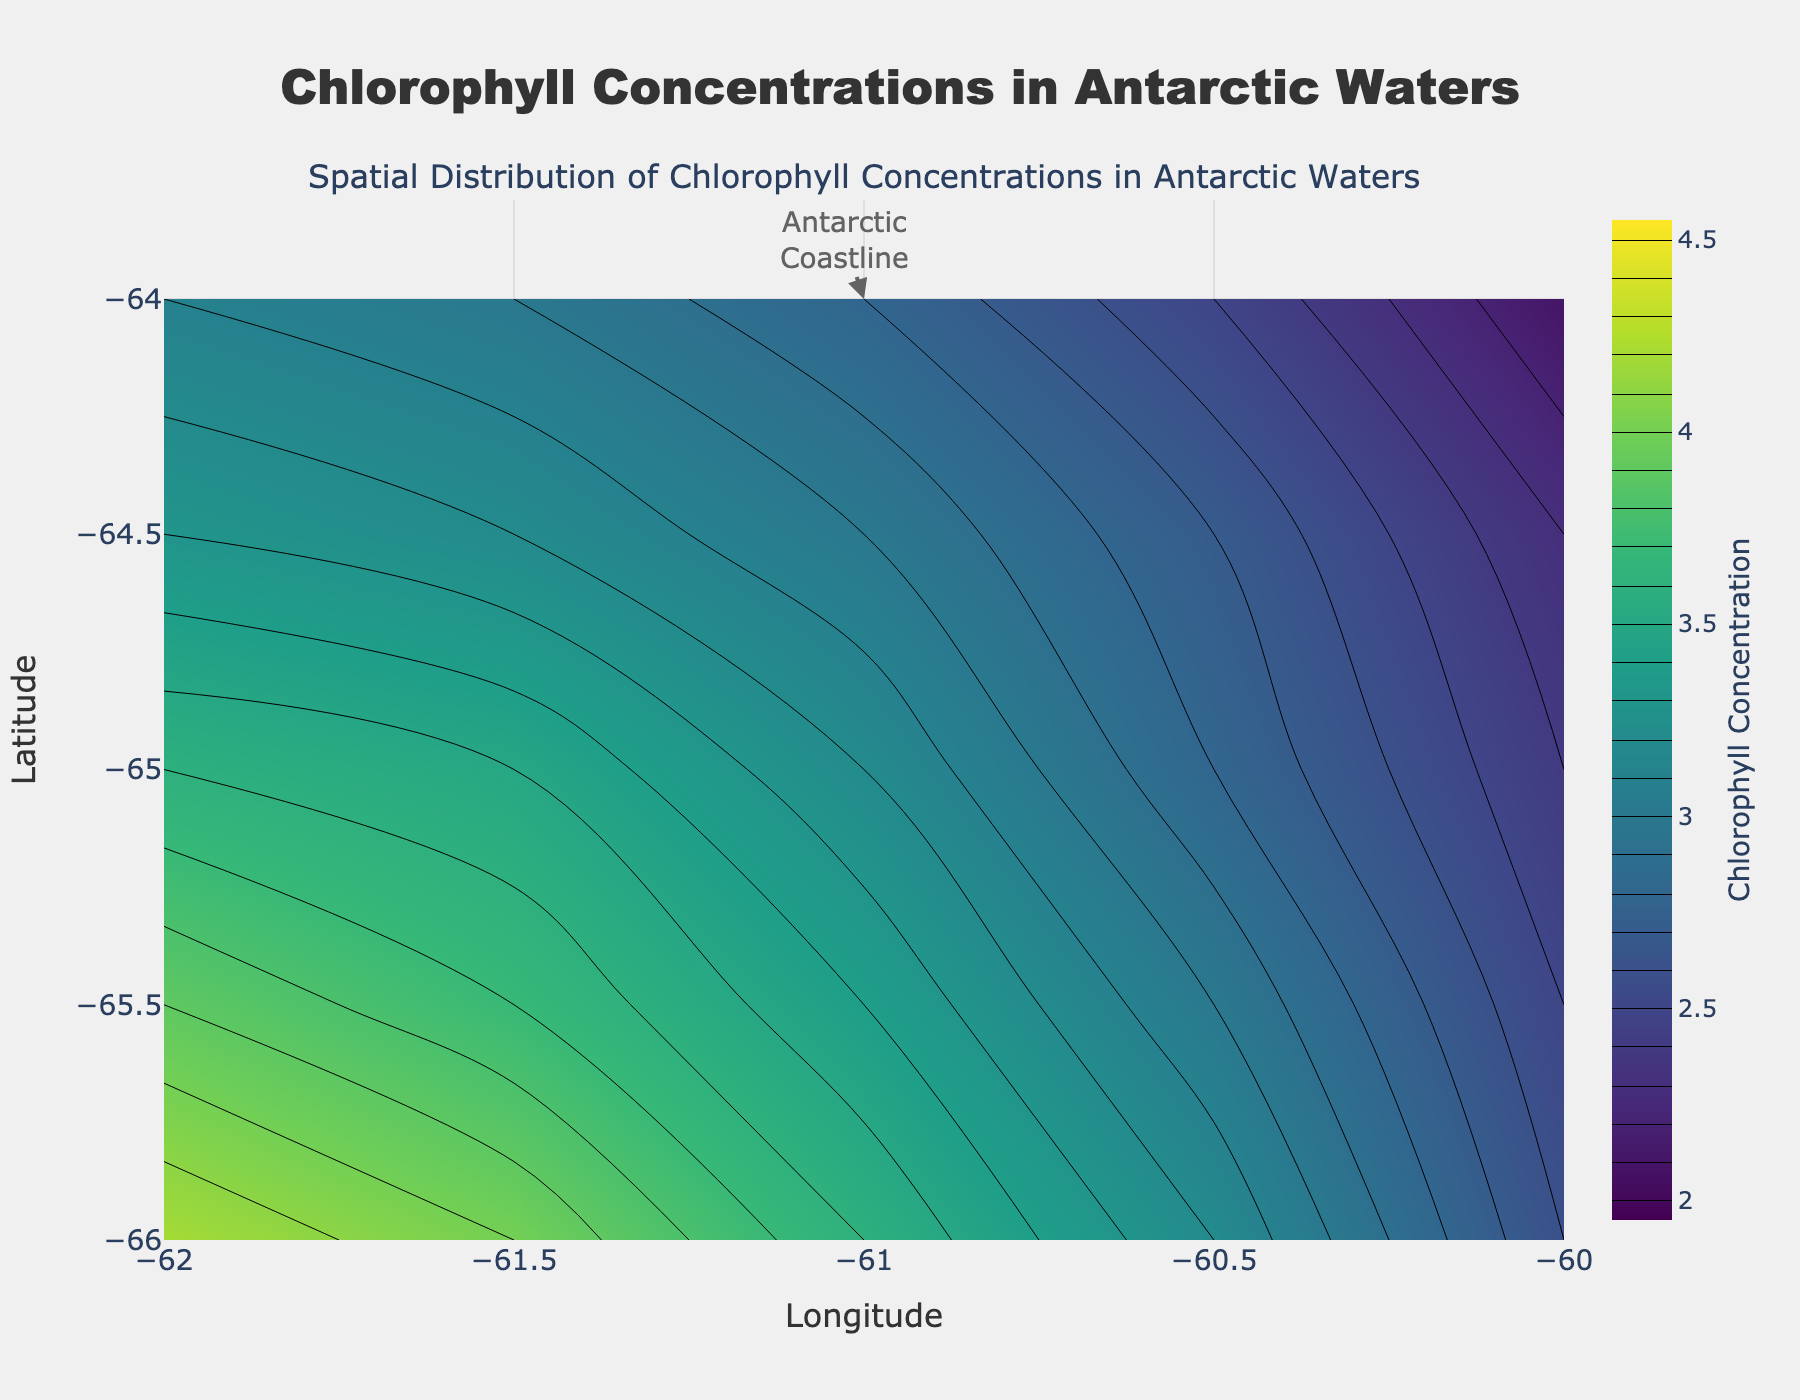What's the title of the figure? The title is located at the top center of the figure in large, bold font. It reads "Chlorophyll Concentrations in Antarctic Waters".
Answer: Chlorophyll Concentrations in Antarctic Waters What are the axis labels in the figure? The x-axis label, located at the bottom center of the plot, reads "Longitude". The y-axis label, located at the left center of the plot, reads "Latitude".
Answer: Longitude and Latitude What color scale is used in the contour plot? The color scale used in the plot is the 'Viridis' colorscale, which ranges from dark blue to yellow. This can be inferred from the color gradient in the contour plot.
Answer: Viridis What's the range of chlorophyll concentration in this plot? The color bar to the right of the contour plot indicates that the chlorophyll concentration ranges from 2 to 4.5. The color bar has labels that show these values.
Answer: 2 to 4.5 Where is the highest concentration of chlorophyll found in the plot? The highest concentration of chlorophyll, indicated by the brightest yellow color in the plot, is located at the bottom right corner, around the coordinates (-66.0, -62.0).
Answer: Around (-66.0, -62.0) Compare the chlorophyll concentration at (-64.0, -60.0) and (-65.5, -61.5). Which one has a higher concentration? The contour plot shows that (-65.5, -61.5) has a concentration of around 3.7, while (-64.0, -60.0) has a concentration of around 2.1. Therefore, the point (-65.5, -61.5) has a higher concentration.
Answer: (-65.5, -61.5) What's the average chlorophyll concentration at the longitude -61.0? By observing the contour lines for the longitude -61.0, the concentrations at different latitudes are 2.4, 2.8, 3.2, 3.5, and 3.6. Calculate the average: (2.4 + 2.8 + 3.2 + 3.5 + 3.6) / 5 = 3.1.
Answer: 3.1 What is the approximate difference in chlorophyll concentration between the points (-64.5, -61.0) and (-66.0, -60.0)? The chlorophyll concentration at (-64.5, -61.0) is approximately 2.8, and at (-66.0, -60.0) it is approximately 3.1. Therefore, the difference is 3.1 - 2.8 = 0.3.
Answer: 0.3 How does the chlorophyll concentration change as you move from (-64.0, -60.0) to (-66.0, -62.0)? As you move from (-64.0, -60.0) to (-66.0, -62.0), the chlorophyll concentration increases gradually, which is shown by the contour lines going from darker to brighter colors. The concentration starts at 2.1 and ends at 4.2.
Answer: It increases What does the annotation at (-61, -64) refer to? The annotation at (-61, -64) with an arrow pointing to a text box that reads "Antarctic Coastline". It indicates the geographical feature of the Antarctic Coastline.
Answer: Antarctic Coastline 